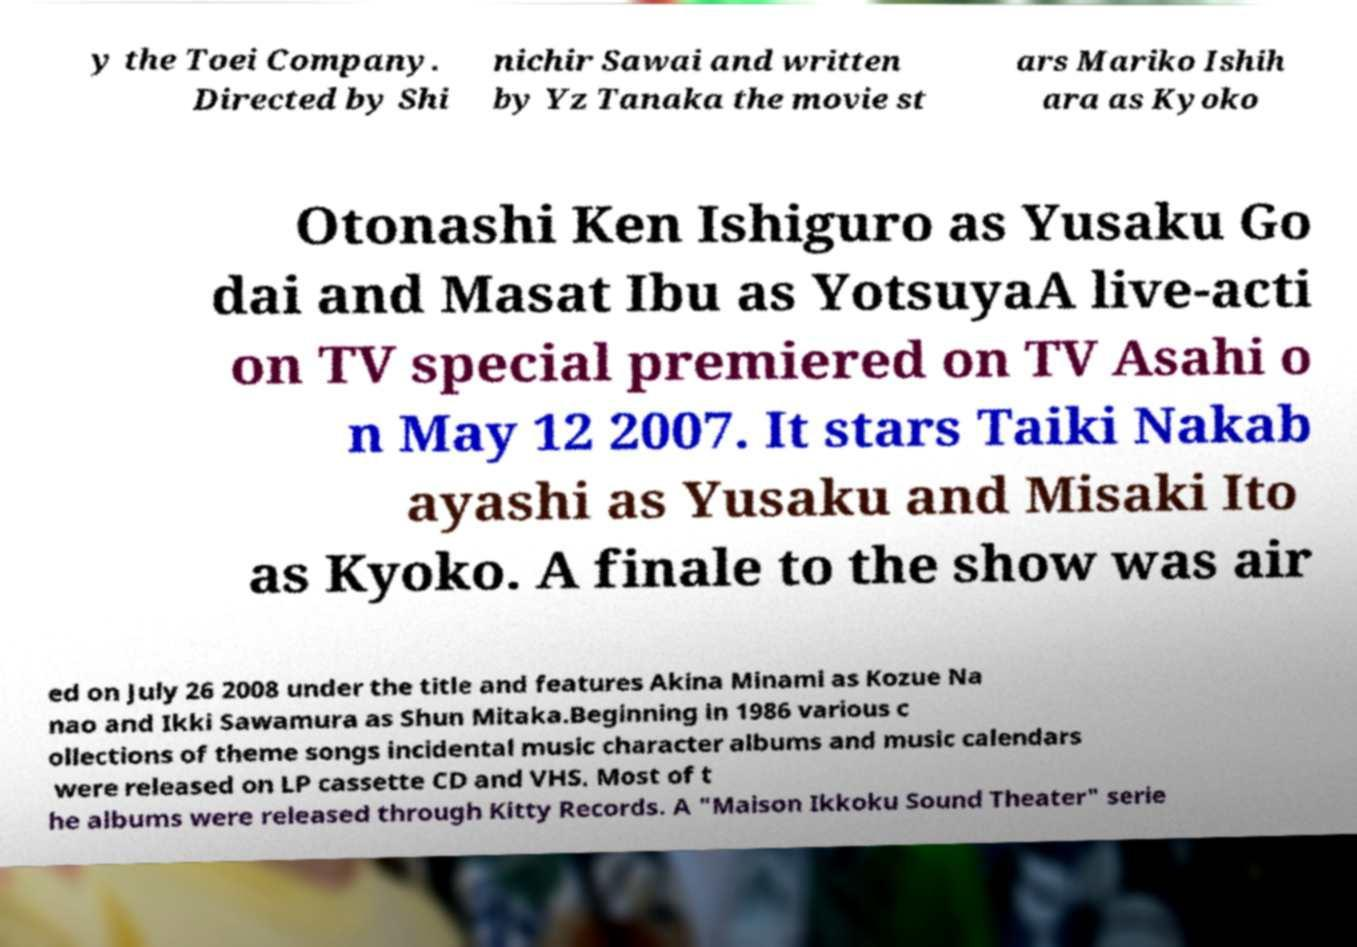Please read and relay the text visible in this image. What does it say? y the Toei Company. Directed by Shi nichir Sawai and written by Yz Tanaka the movie st ars Mariko Ishih ara as Kyoko Otonashi Ken Ishiguro as Yusaku Go dai and Masat Ibu as YotsuyaA live-acti on TV special premiered on TV Asahi o n May 12 2007. It stars Taiki Nakab ayashi as Yusaku and Misaki Ito as Kyoko. A finale to the show was air ed on July 26 2008 under the title and features Akina Minami as Kozue Na nao and Ikki Sawamura as Shun Mitaka.Beginning in 1986 various c ollections of theme songs incidental music character albums and music calendars were released on LP cassette CD and VHS. Most of t he albums were released through Kitty Records. A "Maison Ikkoku Sound Theater" serie 